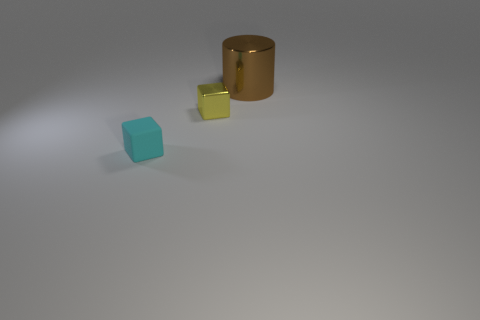Add 2 big blue matte spheres. How many objects exist? 5 Subtract all cylinders. How many objects are left? 2 Add 2 small cyan things. How many small cyan things are left? 3 Add 2 yellow metal objects. How many yellow metal objects exist? 3 Subtract 0 blue cylinders. How many objects are left? 3 Subtract all yellow things. Subtract all small cyan rubber balls. How many objects are left? 2 